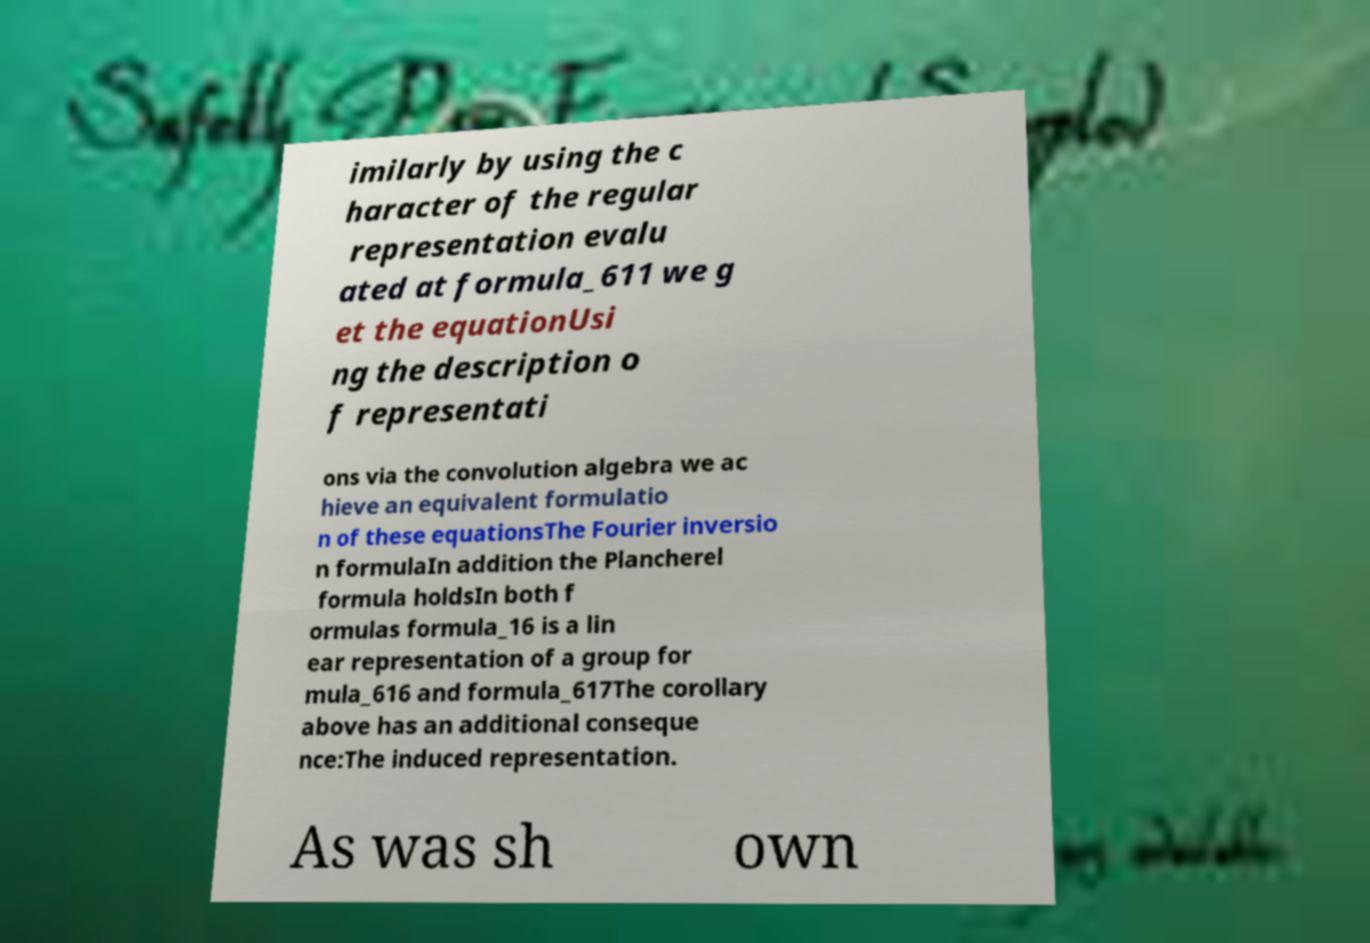What messages or text are displayed in this image? I need them in a readable, typed format. imilarly by using the c haracter of the regular representation evalu ated at formula_611 we g et the equationUsi ng the description o f representati ons via the convolution algebra we ac hieve an equivalent formulatio n of these equationsThe Fourier inversio n formulaIn addition the Plancherel formula holdsIn both f ormulas formula_16 is a lin ear representation of a group for mula_616 and formula_617The corollary above has an additional conseque nce:The induced representation. As was sh own 